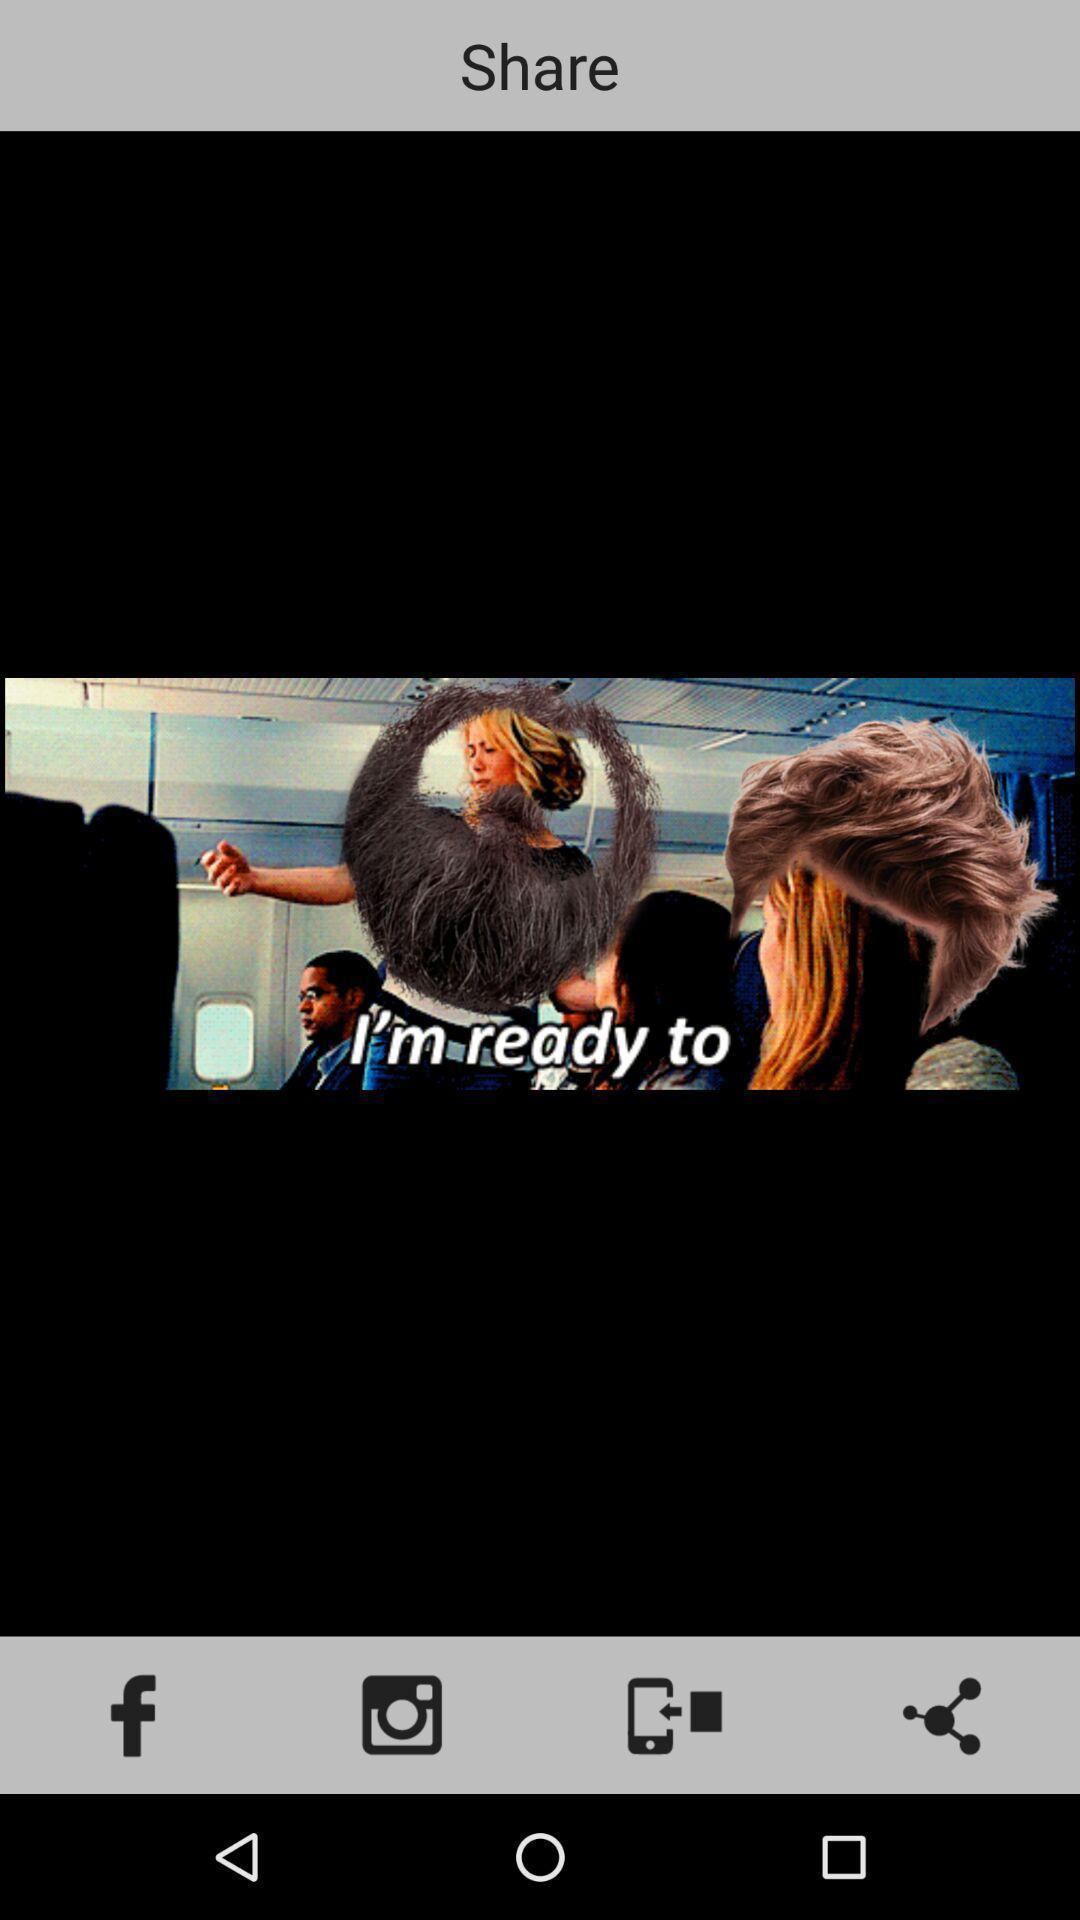Give me a summary of this screen capture. Page showing to share image in social app. 